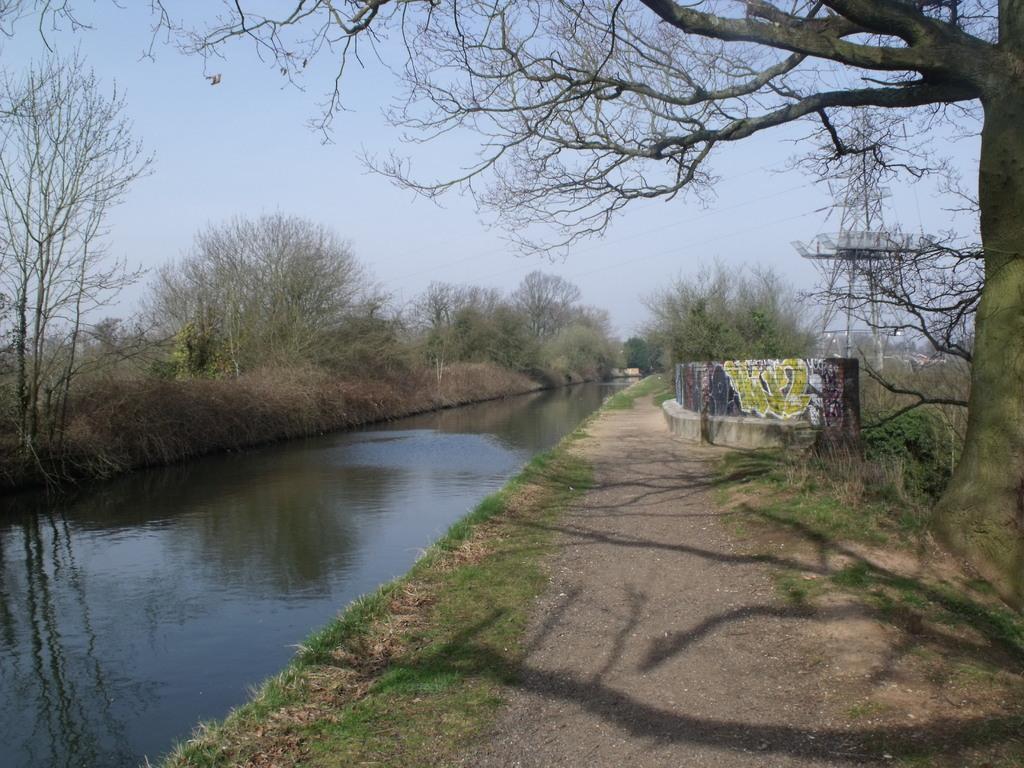Describe this image in one or two sentences. In this image I can see grass, a wall, water, number of trees, a tower, few wires and the sky. I can also see painting on this wall and I can see shadows over here. 